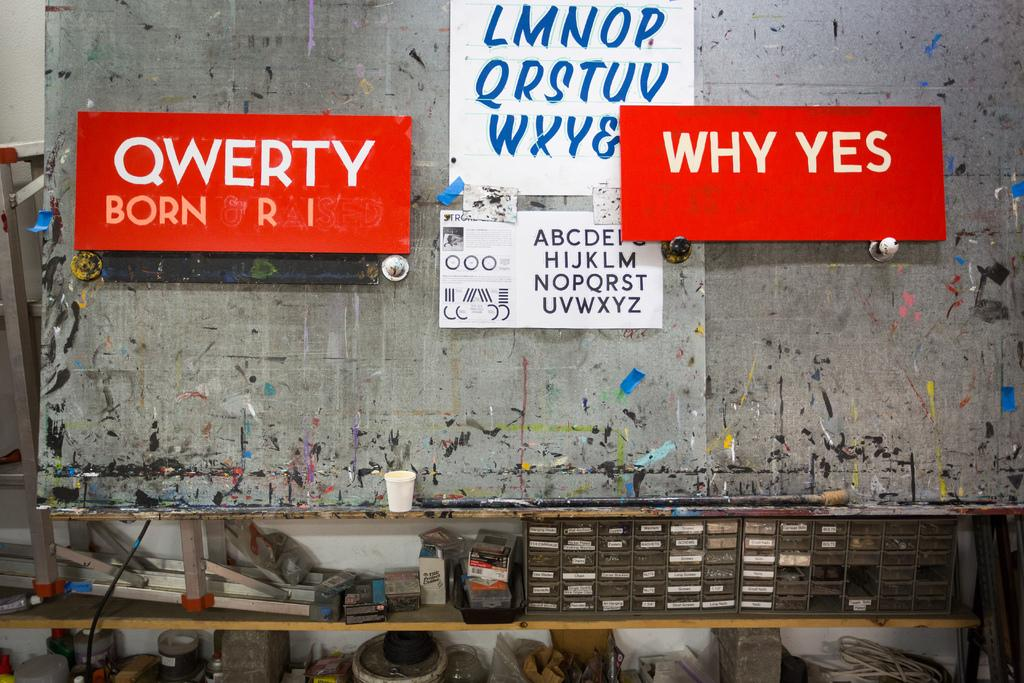<image>
Render a clear and concise summary of the photo. Why Yes is hung on the wall in white letter on a red background. 